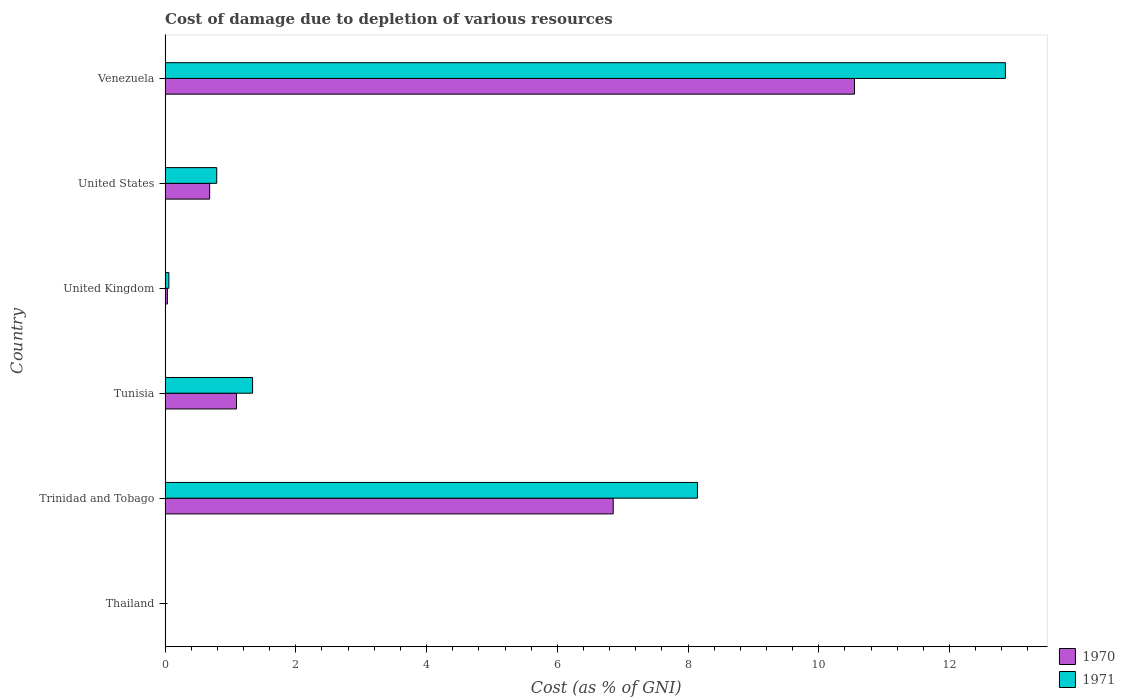Are the number of bars per tick equal to the number of legend labels?
Provide a short and direct response. Yes. Are the number of bars on each tick of the Y-axis equal?
Provide a short and direct response. Yes. How many bars are there on the 5th tick from the top?
Offer a very short reply. 2. How many bars are there on the 4th tick from the bottom?
Keep it short and to the point. 2. What is the label of the 3rd group of bars from the top?
Keep it short and to the point. United Kingdom. In how many cases, is the number of bars for a given country not equal to the number of legend labels?
Your answer should be very brief. 0. What is the cost of damage caused due to the depletion of various resources in 1970 in United Kingdom?
Offer a very short reply. 0.03. Across all countries, what is the maximum cost of damage caused due to the depletion of various resources in 1970?
Offer a terse response. 10.55. Across all countries, what is the minimum cost of damage caused due to the depletion of various resources in 1970?
Your answer should be compact. 0. In which country was the cost of damage caused due to the depletion of various resources in 1970 maximum?
Offer a terse response. Venezuela. In which country was the cost of damage caused due to the depletion of various resources in 1971 minimum?
Keep it short and to the point. Thailand. What is the total cost of damage caused due to the depletion of various resources in 1971 in the graph?
Your response must be concise. 23.19. What is the difference between the cost of damage caused due to the depletion of various resources in 1970 in Trinidad and Tobago and that in Venezuela?
Your response must be concise. -3.69. What is the difference between the cost of damage caused due to the depletion of various resources in 1970 in United States and the cost of damage caused due to the depletion of various resources in 1971 in Thailand?
Ensure brevity in your answer.  0.68. What is the average cost of damage caused due to the depletion of various resources in 1970 per country?
Offer a very short reply. 3.2. What is the difference between the cost of damage caused due to the depletion of various resources in 1970 and cost of damage caused due to the depletion of various resources in 1971 in Tunisia?
Give a very brief answer. -0.25. In how many countries, is the cost of damage caused due to the depletion of various resources in 1971 greater than 2.8 %?
Your answer should be compact. 2. What is the ratio of the cost of damage caused due to the depletion of various resources in 1971 in Tunisia to that in Venezuela?
Your answer should be compact. 0.1. Is the difference between the cost of damage caused due to the depletion of various resources in 1970 in Trinidad and Tobago and Tunisia greater than the difference between the cost of damage caused due to the depletion of various resources in 1971 in Trinidad and Tobago and Tunisia?
Provide a succinct answer. No. What is the difference between the highest and the second highest cost of damage caused due to the depletion of various resources in 1971?
Give a very brief answer. 4.71. What is the difference between the highest and the lowest cost of damage caused due to the depletion of various resources in 1971?
Offer a terse response. 12.85. In how many countries, is the cost of damage caused due to the depletion of various resources in 1970 greater than the average cost of damage caused due to the depletion of various resources in 1970 taken over all countries?
Offer a very short reply. 2. Is the sum of the cost of damage caused due to the depletion of various resources in 1970 in United Kingdom and Venezuela greater than the maximum cost of damage caused due to the depletion of various resources in 1971 across all countries?
Your response must be concise. No. What does the 1st bar from the top in United Kingdom represents?
Keep it short and to the point. 1971. How many countries are there in the graph?
Make the answer very short. 6. Does the graph contain any zero values?
Make the answer very short. No. What is the title of the graph?
Your response must be concise. Cost of damage due to depletion of various resources. Does "1977" appear as one of the legend labels in the graph?
Your answer should be very brief. No. What is the label or title of the X-axis?
Ensure brevity in your answer.  Cost (as % of GNI). What is the Cost (as % of GNI) in 1970 in Thailand?
Make the answer very short. 0. What is the Cost (as % of GNI) in 1971 in Thailand?
Provide a succinct answer. 0. What is the Cost (as % of GNI) of 1970 in Trinidad and Tobago?
Give a very brief answer. 6.86. What is the Cost (as % of GNI) of 1971 in Trinidad and Tobago?
Offer a terse response. 8.14. What is the Cost (as % of GNI) in 1970 in Tunisia?
Ensure brevity in your answer.  1.09. What is the Cost (as % of GNI) in 1971 in Tunisia?
Provide a short and direct response. 1.34. What is the Cost (as % of GNI) in 1970 in United Kingdom?
Your answer should be compact. 0.03. What is the Cost (as % of GNI) of 1971 in United Kingdom?
Ensure brevity in your answer.  0.06. What is the Cost (as % of GNI) of 1970 in United States?
Provide a short and direct response. 0.68. What is the Cost (as % of GNI) of 1971 in United States?
Provide a short and direct response. 0.79. What is the Cost (as % of GNI) of 1970 in Venezuela?
Provide a short and direct response. 10.55. What is the Cost (as % of GNI) of 1971 in Venezuela?
Your response must be concise. 12.86. Across all countries, what is the maximum Cost (as % of GNI) of 1970?
Your answer should be very brief. 10.55. Across all countries, what is the maximum Cost (as % of GNI) of 1971?
Your answer should be compact. 12.86. Across all countries, what is the minimum Cost (as % of GNI) of 1970?
Give a very brief answer. 0. Across all countries, what is the minimum Cost (as % of GNI) of 1971?
Your answer should be compact. 0. What is the total Cost (as % of GNI) in 1970 in the graph?
Give a very brief answer. 19.21. What is the total Cost (as % of GNI) in 1971 in the graph?
Offer a terse response. 23.19. What is the difference between the Cost (as % of GNI) of 1970 in Thailand and that in Trinidad and Tobago?
Offer a terse response. -6.85. What is the difference between the Cost (as % of GNI) in 1971 in Thailand and that in Trinidad and Tobago?
Your answer should be compact. -8.14. What is the difference between the Cost (as % of GNI) in 1970 in Thailand and that in Tunisia?
Provide a succinct answer. -1.09. What is the difference between the Cost (as % of GNI) in 1971 in Thailand and that in Tunisia?
Offer a very short reply. -1.33. What is the difference between the Cost (as % of GNI) of 1970 in Thailand and that in United Kingdom?
Your answer should be very brief. -0.03. What is the difference between the Cost (as % of GNI) in 1971 in Thailand and that in United Kingdom?
Your response must be concise. -0.05. What is the difference between the Cost (as % of GNI) in 1970 in Thailand and that in United States?
Give a very brief answer. -0.68. What is the difference between the Cost (as % of GNI) of 1971 in Thailand and that in United States?
Make the answer very short. -0.79. What is the difference between the Cost (as % of GNI) in 1970 in Thailand and that in Venezuela?
Provide a succinct answer. -10.55. What is the difference between the Cost (as % of GNI) in 1971 in Thailand and that in Venezuela?
Keep it short and to the point. -12.85. What is the difference between the Cost (as % of GNI) in 1970 in Trinidad and Tobago and that in Tunisia?
Provide a succinct answer. 5.76. What is the difference between the Cost (as % of GNI) of 1971 in Trinidad and Tobago and that in Tunisia?
Your answer should be compact. 6.81. What is the difference between the Cost (as % of GNI) of 1970 in Trinidad and Tobago and that in United Kingdom?
Your response must be concise. 6.82. What is the difference between the Cost (as % of GNI) in 1971 in Trinidad and Tobago and that in United Kingdom?
Offer a very short reply. 8.09. What is the difference between the Cost (as % of GNI) in 1970 in Trinidad and Tobago and that in United States?
Provide a short and direct response. 6.17. What is the difference between the Cost (as % of GNI) of 1971 in Trinidad and Tobago and that in United States?
Make the answer very short. 7.35. What is the difference between the Cost (as % of GNI) of 1970 in Trinidad and Tobago and that in Venezuela?
Your response must be concise. -3.69. What is the difference between the Cost (as % of GNI) in 1971 in Trinidad and Tobago and that in Venezuela?
Your answer should be compact. -4.71. What is the difference between the Cost (as % of GNI) of 1970 in Tunisia and that in United Kingdom?
Keep it short and to the point. 1.06. What is the difference between the Cost (as % of GNI) in 1971 in Tunisia and that in United Kingdom?
Provide a short and direct response. 1.28. What is the difference between the Cost (as % of GNI) of 1970 in Tunisia and that in United States?
Ensure brevity in your answer.  0.41. What is the difference between the Cost (as % of GNI) in 1971 in Tunisia and that in United States?
Keep it short and to the point. 0.55. What is the difference between the Cost (as % of GNI) of 1970 in Tunisia and that in Venezuela?
Provide a succinct answer. -9.45. What is the difference between the Cost (as % of GNI) in 1971 in Tunisia and that in Venezuela?
Your answer should be very brief. -11.52. What is the difference between the Cost (as % of GNI) of 1970 in United Kingdom and that in United States?
Make the answer very short. -0.65. What is the difference between the Cost (as % of GNI) in 1971 in United Kingdom and that in United States?
Your answer should be very brief. -0.73. What is the difference between the Cost (as % of GNI) in 1970 in United Kingdom and that in Venezuela?
Provide a short and direct response. -10.51. What is the difference between the Cost (as % of GNI) of 1971 in United Kingdom and that in Venezuela?
Make the answer very short. -12.8. What is the difference between the Cost (as % of GNI) in 1970 in United States and that in Venezuela?
Your answer should be compact. -9.86. What is the difference between the Cost (as % of GNI) of 1971 in United States and that in Venezuela?
Keep it short and to the point. -12.07. What is the difference between the Cost (as % of GNI) in 1970 in Thailand and the Cost (as % of GNI) in 1971 in Trinidad and Tobago?
Offer a very short reply. -8.14. What is the difference between the Cost (as % of GNI) of 1970 in Thailand and the Cost (as % of GNI) of 1971 in Tunisia?
Make the answer very short. -1.34. What is the difference between the Cost (as % of GNI) in 1970 in Thailand and the Cost (as % of GNI) in 1971 in United Kingdom?
Make the answer very short. -0.06. What is the difference between the Cost (as % of GNI) of 1970 in Thailand and the Cost (as % of GNI) of 1971 in United States?
Make the answer very short. -0.79. What is the difference between the Cost (as % of GNI) of 1970 in Thailand and the Cost (as % of GNI) of 1971 in Venezuela?
Provide a succinct answer. -12.85. What is the difference between the Cost (as % of GNI) in 1970 in Trinidad and Tobago and the Cost (as % of GNI) in 1971 in Tunisia?
Make the answer very short. 5.52. What is the difference between the Cost (as % of GNI) of 1970 in Trinidad and Tobago and the Cost (as % of GNI) of 1971 in United Kingdom?
Offer a terse response. 6.8. What is the difference between the Cost (as % of GNI) of 1970 in Trinidad and Tobago and the Cost (as % of GNI) of 1971 in United States?
Offer a terse response. 6.07. What is the difference between the Cost (as % of GNI) in 1970 in Trinidad and Tobago and the Cost (as % of GNI) in 1971 in Venezuela?
Keep it short and to the point. -6. What is the difference between the Cost (as % of GNI) of 1970 in Tunisia and the Cost (as % of GNI) of 1971 in United Kingdom?
Your response must be concise. 1.03. What is the difference between the Cost (as % of GNI) of 1970 in Tunisia and the Cost (as % of GNI) of 1971 in United States?
Ensure brevity in your answer.  0.3. What is the difference between the Cost (as % of GNI) of 1970 in Tunisia and the Cost (as % of GNI) of 1971 in Venezuela?
Your answer should be very brief. -11.76. What is the difference between the Cost (as % of GNI) of 1970 in United Kingdom and the Cost (as % of GNI) of 1971 in United States?
Your answer should be compact. -0.76. What is the difference between the Cost (as % of GNI) of 1970 in United Kingdom and the Cost (as % of GNI) of 1971 in Venezuela?
Provide a short and direct response. -12.82. What is the difference between the Cost (as % of GNI) in 1970 in United States and the Cost (as % of GNI) in 1971 in Venezuela?
Provide a succinct answer. -12.17. What is the average Cost (as % of GNI) in 1970 per country?
Keep it short and to the point. 3.2. What is the average Cost (as % of GNI) of 1971 per country?
Your response must be concise. 3.86. What is the difference between the Cost (as % of GNI) in 1970 and Cost (as % of GNI) in 1971 in Thailand?
Your response must be concise. -0. What is the difference between the Cost (as % of GNI) in 1970 and Cost (as % of GNI) in 1971 in Trinidad and Tobago?
Keep it short and to the point. -1.29. What is the difference between the Cost (as % of GNI) of 1970 and Cost (as % of GNI) of 1971 in Tunisia?
Your answer should be compact. -0.25. What is the difference between the Cost (as % of GNI) in 1970 and Cost (as % of GNI) in 1971 in United Kingdom?
Offer a very short reply. -0.02. What is the difference between the Cost (as % of GNI) in 1970 and Cost (as % of GNI) in 1971 in United States?
Your answer should be compact. -0.11. What is the difference between the Cost (as % of GNI) of 1970 and Cost (as % of GNI) of 1971 in Venezuela?
Offer a terse response. -2.31. What is the ratio of the Cost (as % of GNI) in 1971 in Thailand to that in Trinidad and Tobago?
Give a very brief answer. 0. What is the ratio of the Cost (as % of GNI) in 1970 in Thailand to that in Tunisia?
Offer a terse response. 0. What is the ratio of the Cost (as % of GNI) in 1971 in Thailand to that in Tunisia?
Ensure brevity in your answer.  0. What is the ratio of the Cost (as % of GNI) of 1970 in Thailand to that in United Kingdom?
Your answer should be compact. 0.04. What is the ratio of the Cost (as % of GNI) in 1971 in Thailand to that in United Kingdom?
Make the answer very short. 0.06. What is the ratio of the Cost (as % of GNI) of 1970 in Thailand to that in United States?
Your answer should be very brief. 0. What is the ratio of the Cost (as % of GNI) of 1971 in Thailand to that in United States?
Make the answer very short. 0. What is the ratio of the Cost (as % of GNI) of 1970 in Thailand to that in Venezuela?
Your answer should be compact. 0. What is the ratio of the Cost (as % of GNI) in 1971 in Thailand to that in Venezuela?
Provide a short and direct response. 0. What is the ratio of the Cost (as % of GNI) of 1970 in Trinidad and Tobago to that in Tunisia?
Your answer should be very brief. 6.28. What is the ratio of the Cost (as % of GNI) in 1971 in Trinidad and Tobago to that in Tunisia?
Offer a terse response. 6.09. What is the ratio of the Cost (as % of GNI) of 1970 in Trinidad and Tobago to that in United Kingdom?
Your answer should be compact. 196.43. What is the ratio of the Cost (as % of GNI) of 1971 in Trinidad and Tobago to that in United Kingdom?
Your answer should be compact. 141.45. What is the ratio of the Cost (as % of GNI) of 1970 in Trinidad and Tobago to that in United States?
Offer a very short reply. 10.06. What is the ratio of the Cost (as % of GNI) of 1971 in Trinidad and Tobago to that in United States?
Ensure brevity in your answer.  10.31. What is the ratio of the Cost (as % of GNI) of 1970 in Trinidad and Tobago to that in Venezuela?
Make the answer very short. 0.65. What is the ratio of the Cost (as % of GNI) in 1971 in Trinidad and Tobago to that in Venezuela?
Your answer should be compact. 0.63. What is the ratio of the Cost (as % of GNI) in 1970 in Tunisia to that in United Kingdom?
Provide a succinct answer. 31.3. What is the ratio of the Cost (as % of GNI) in 1971 in Tunisia to that in United Kingdom?
Keep it short and to the point. 23.24. What is the ratio of the Cost (as % of GNI) in 1970 in Tunisia to that in United States?
Your response must be concise. 1.6. What is the ratio of the Cost (as % of GNI) in 1971 in Tunisia to that in United States?
Provide a short and direct response. 1.69. What is the ratio of the Cost (as % of GNI) in 1970 in Tunisia to that in Venezuela?
Offer a terse response. 0.1. What is the ratio of the Cost (as % of GNI) of 1971 in Tunisia to that in Venezuela?
Provide a succinct answer. 0.1. What is the ratio of the Cost (as % of GNI) of 1970 in United Kingdom to that in United States?
Your response must be concise. 0.05. What is the ratio of the Cost (as % of GNI) in 1971 in United Kingdom to that in United States?
Give a very brief answer. 0.07. What is the ratio of the Cost (as % of GNI) in 1970 in United Kingdom to that in Venezuela?
Your answer should be compact. 0. What is the ratio of the Cost (as % of GNI) in 1971 in United Kingdom to that in Venezuela?
Ensure brevity in your answer.  0. What is the ratio of the Cost (as % of GNI) of 1970 in United States to that in Venezuela?
Make the answer very short. 0.06. What is the ratio of the Cost (as % of GNI) of 1971 in United States to that in Venezuela?
Provide a succinct answer. 0.06. What is the difference between the highest and the second highest Cost (as % of GNI) of 1970?
Offer a very short reply. 3.69. What is the difference between the highest and the second highest Cost (as % of GNI) in 1971?
Make the answer very short. 4.71. What is the difference between the highest and the lowest Cost (as % of GNI) in 1970?
Offer a very short reply. 10.55. What is the difference between the highest and the lowest Cost (as % of GNI) of 1971?
Provide a succinct answer. 12.85. 